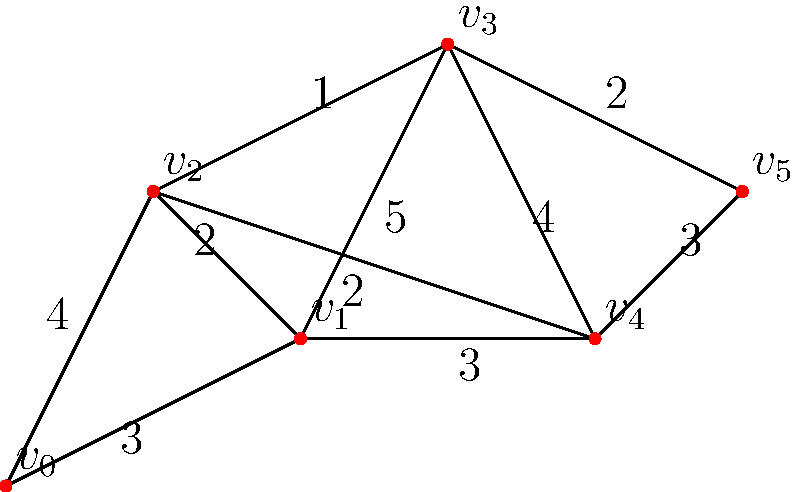In the given building layout, vertices represent junction boxes and edges represent potential wiring paths with their associated lengths (in meters). What is the shortest path for electrical wiring from junction box $v_0$ to junction box $v_5$, and what is its total length? To find the shortest path, we'll use Dijkstra's algorithm:

1. Initialize:
   - Distance to $v_0$: 0
   - Distance to all other vertices: $\infty$
   - Previous vertex for all: undefined
   - Unvisited set: {$v_0$, $v_1$, $v_2$, $v_3$, $v_4$, $v_5$}

2. From $v_0$:
   - Update $v_1$: distance = 3
   - Update $v_2$: distance = 4
   - Mark $v_0$ as visited

3. From $v_1$ (closest unvisited):
   - Update $v_2$: distance = min(4, 3+2) = 4 (no change)
   - Update $v_3$: distance = 3+5 = 8
   - Update $v_4$: distance = 3+3 = 6
   - Mark $v_1$ as visited

4. From $v_2$ (closest unvisited):
   - Update $v_3$: distance = min(8, 4+1) = 5
   - Update $v_4$: distance = min(6, 4+2) = 6 (no change)
   - Mark $v_2$ as visited

5. From $v_3$ (closest unvisited):
   - Update $v_4$: distance = min(6, 5+4) = 6 (no change)
   - Update $v_5$: distance = 5+2 = 7
   - Mark $v_3$ as visited

6. From $v_4$ (closest unvisited):
   - Update $v_5$: distance = min(7, 6+3) = 7 (no change)
   - Mark $v_4$ as visited

7. $v_5$ is the target, so we're done.

Tracing back the path: $v_5 \leftarrow v_3 \leftarrow v_2 \leftarrow v_0$

The shortest path is $v_0 \rightarrow v_2 \rightarrow v_3 \rightarrow v_5$ with a total length of 7 meters.
Answer: $v_0 \rightarrow v_2 \rightarrow v_3 \rightarrow v_5$, 7 meters 